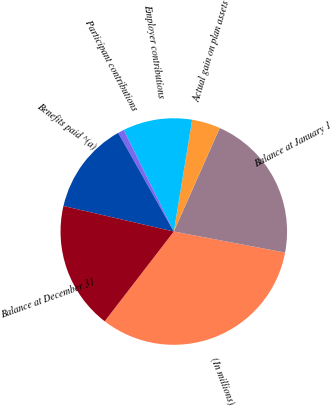<chart> <loc_0><loc_0><loc_500><loc_500><pie_chart><fcel>(In millions)<fcel>Balance at January 1<fcel>Actual gain on plan assets<fcel>Employer contributions<fcel>Participant contributions<fcel>Benefits paid ^(a)<fcel>Balance at December 31<nl><fcel>32.47%<fcel>21.33%<fcel>4.05%<fcel>9.87%<fcel>0.89%<fcel>13.21%<fcel>18.17%<nl></chart> 